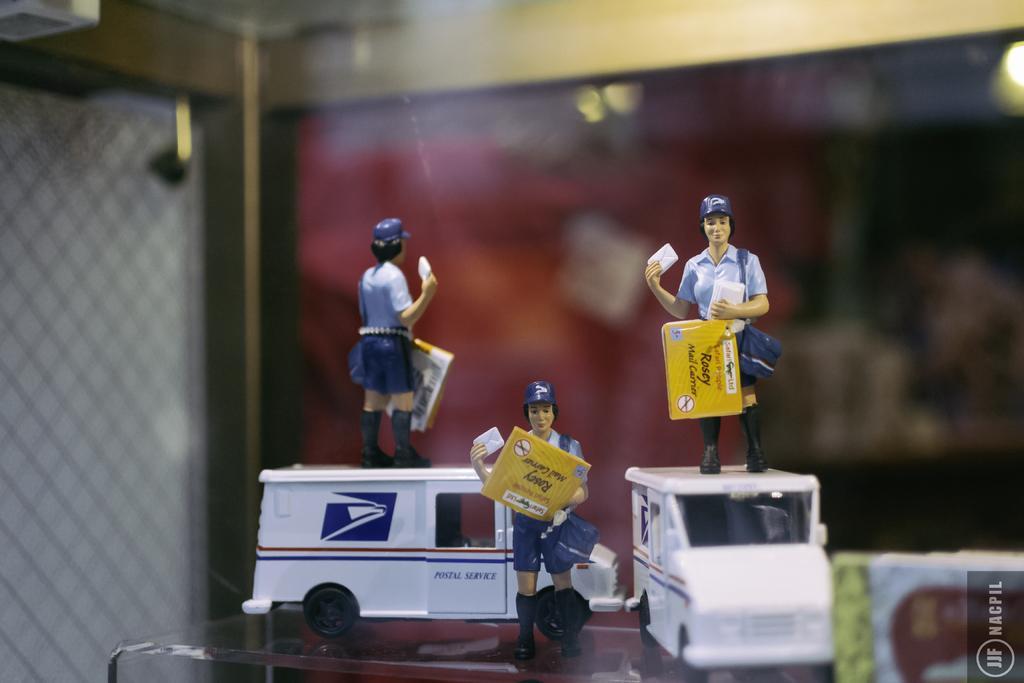Please provide a concise description of this image. In this image in the center there are toys and the background is blurry. 